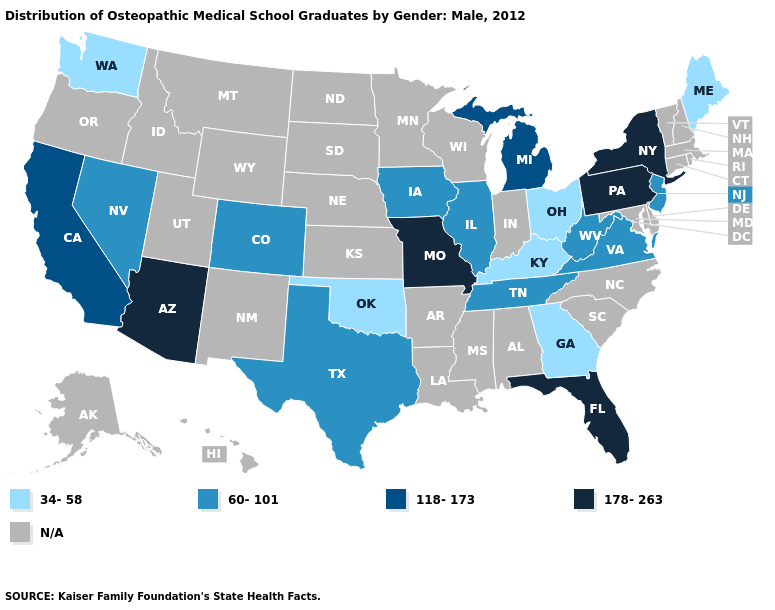Name the states that have a value in the range 178-263?
Keep it brief. Arizona, Florida, Missouri, New York, Pennsylvania. What is the value of South Dakota?
Quick response, please. N/A. Name the states that have a value in the range N/A?
Be succinct. Alabama, Alaska, Arkansas, Connecticut, Delaware, Hawaii, Idaho, Indiana, Kansas, Louisiana, Maryland, Massachusetts, Minnesota, Mississippi, Montana, Nebraska, New Hampshire, New Mexico, North Carolina, North Dakota, Oregon, Rhode Island, South Carolina, South Dakota, Utah, Vermont, Wisconsin, Wyoming. What is the value of Illinois?
Concise answer only. 60-101. How many symbols are there in the legend?
Answer briefly. 5. What is the lowest value in the USA?
Quick response, please. 34-58. How many symbols are there in the legend?
Short answer required. 5. Does the map have missing data?
Write a very short answer. Yes. What is the value of New Jersey?
Short answer required. 60-101. Is the legend a continuous bar?
Concise answer only. No. What is the lowest value in the USA?
Quick response, please. 34-58. Does the map have missing data?
Answer briefly. Yes. Name the states that have a value in the range N/A?
Concise answer only. Alabama, Alaska, Arkansas, Connecticut, Delaware, Hawaii, Idaho, Indiana, Kansas, Louisiana, Maryland, Massachusetts, Minnesota, Mississippi, Montana, Nebraska, New Hampshire, New Mexico, North Carolina, North Dakota, Oregon, Rhode Island, South Carolina, South Dakota, Utah, Vermont, Wisconsin, Wyoming. What is the lowest value in the South?
Concise answer only. 34-58. Does the map have missing data?
Answer briefly. Yes. 